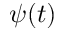<formula> <loc_0><loc_0><loc_500><loc_500>\psi ( t )</formula> 